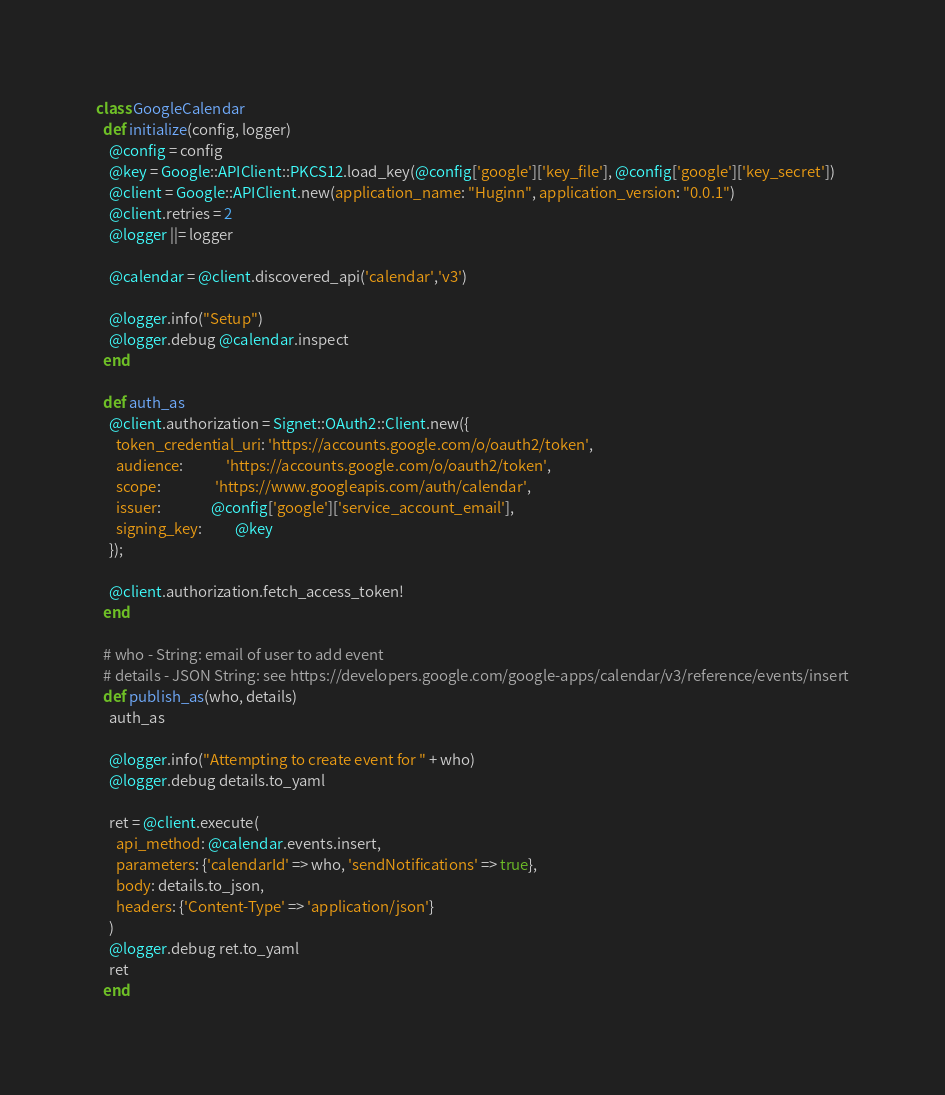<code> <loc_0><loc_0><loc_500><loc_500><_Ruby_>class GoogleCalendar
  def initialize(config, logger)
    @config = config
    @key = Google::APIClient::PKCS12.load_key(@config['google']['key_file'], @config['google']['key_secret'])
    @client = Google::APIClient.new(application_name: "Huginn", application_version: "0.0.1")
    @client.retries = 2
    @logger ||= logger

    @calendar = @client.discovered_api('calendar','v3')

    @logger.info("Setup")
    @logger.debug @calendar.inspect
  end

  def auth_as
    @client.authorization = Signet::OAuth2::Client.new({
      token_credential_uri: 'https://accounts.google.com/o/oauth2/token',
      audience:             'https://accounts.google.com/o/oauth2/token',
      scope:                'https://www.googleapis.com/auth/calendar',
      issuer:               @config['google']['service_account_email'],
      signing_key:          @key
    });

    @client.authorization.fetch_access_token!
  end

  # who - String: email of user to add event
  # details - JSON String: see https://developers.google.com/google-apps/calendar/v3/reference/events/insert
  def publish_as(who, details)
    auth_as

    @logger.info("Attempting to create event for " + who)
    @logger.debug details.to_yaml

    ret = @client.execute(
      api_method: @calendar.events.insert,
      parameters: {'calendarId' => who, 'sendNotifications' => true},
      body: details.to_json,
      headers: {'Content-Type' => 'application/json'}
    )
    @logger.debug ret.to_yaml
    ret
  end
</code> 